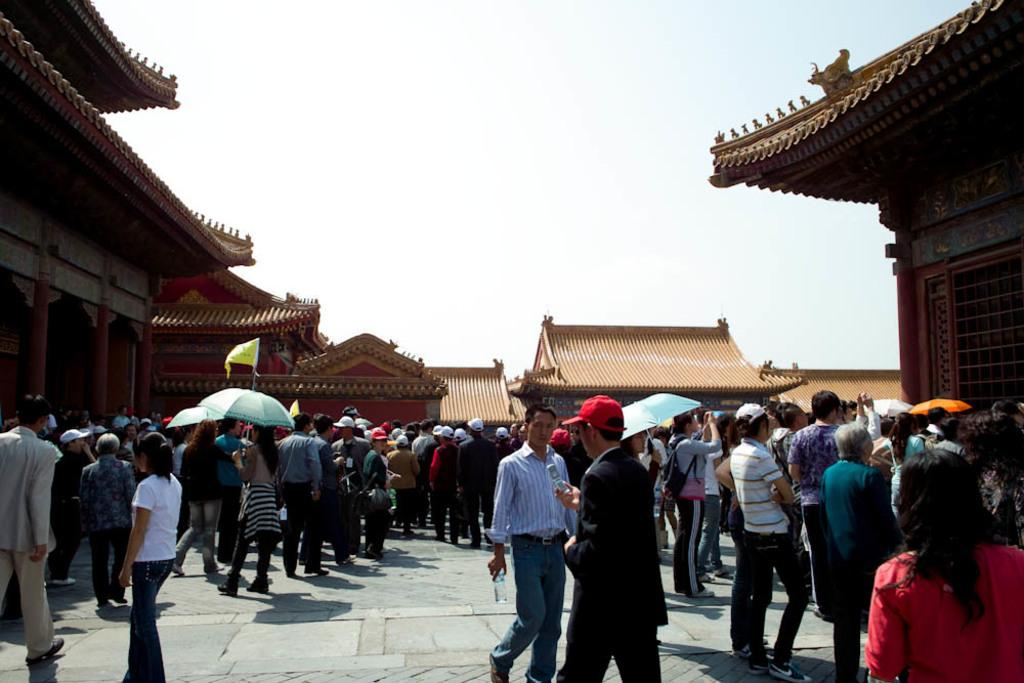What is the main subject of the image? The main subject of the image is a group of people. What are the people in the image doing? The people are standing. Can you describe the clothing or accessories of some people in the image? Some people are wearing caps. What objects are being used by some people in the image? Some people are holding umbrellas. What can be seen in the background of the image? There are houses visible around the group of people. What type of cough can be heard from the people in the image? There is no indication of any coughs in the image, as it only shows a group of people standing and holding umbrellas. Can you tell me how many tanks are visible in the image? There are no tanks present in the image; it features a group of people standing with umbrellas and houses in the background. 